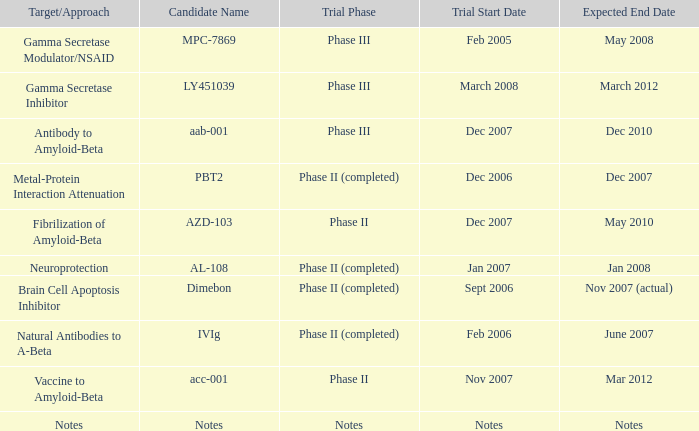What is Trial Start Date, when Candidate Name is Notes? Notes. 